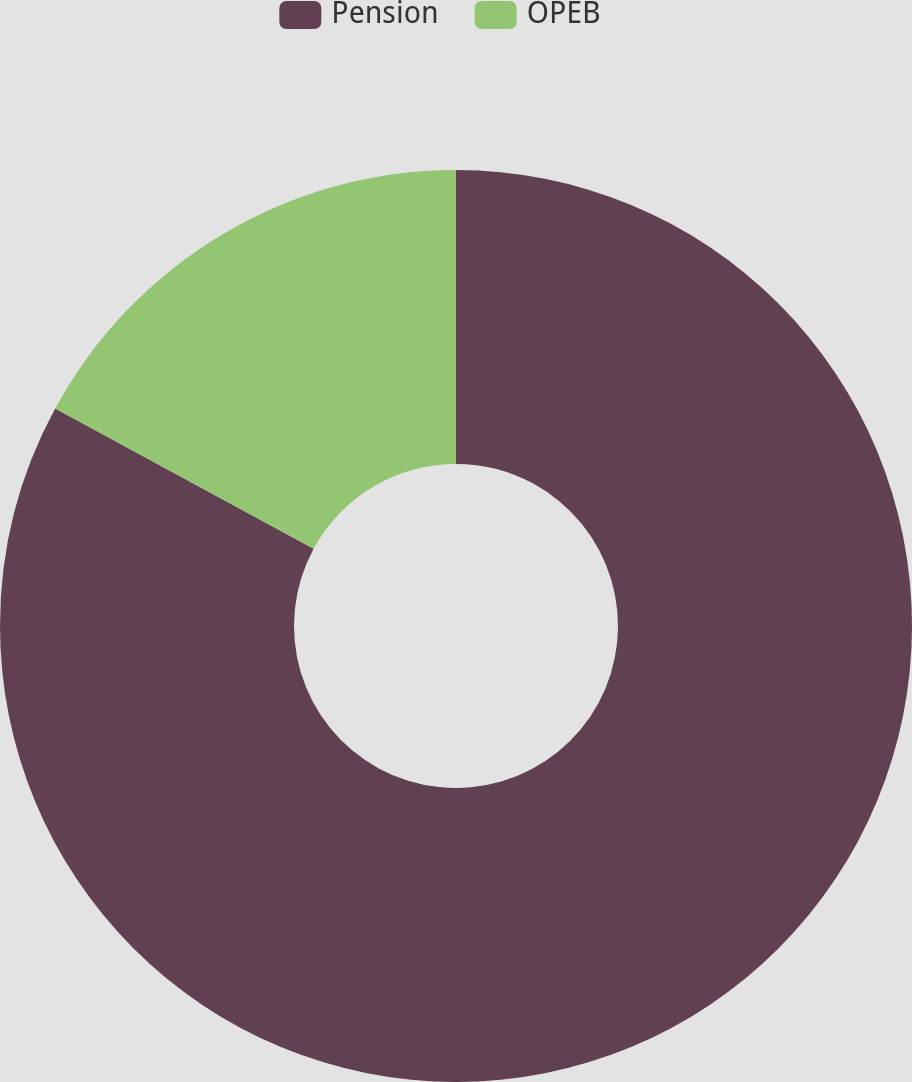Convert chart to OTSL. <chart><loc_0><loc_0><loc_500><loc_500><pie_chart><fcel>Pension<fcel>OPEB<nl><fcel>82.91%<fcel>17.09%<nl></chart> 